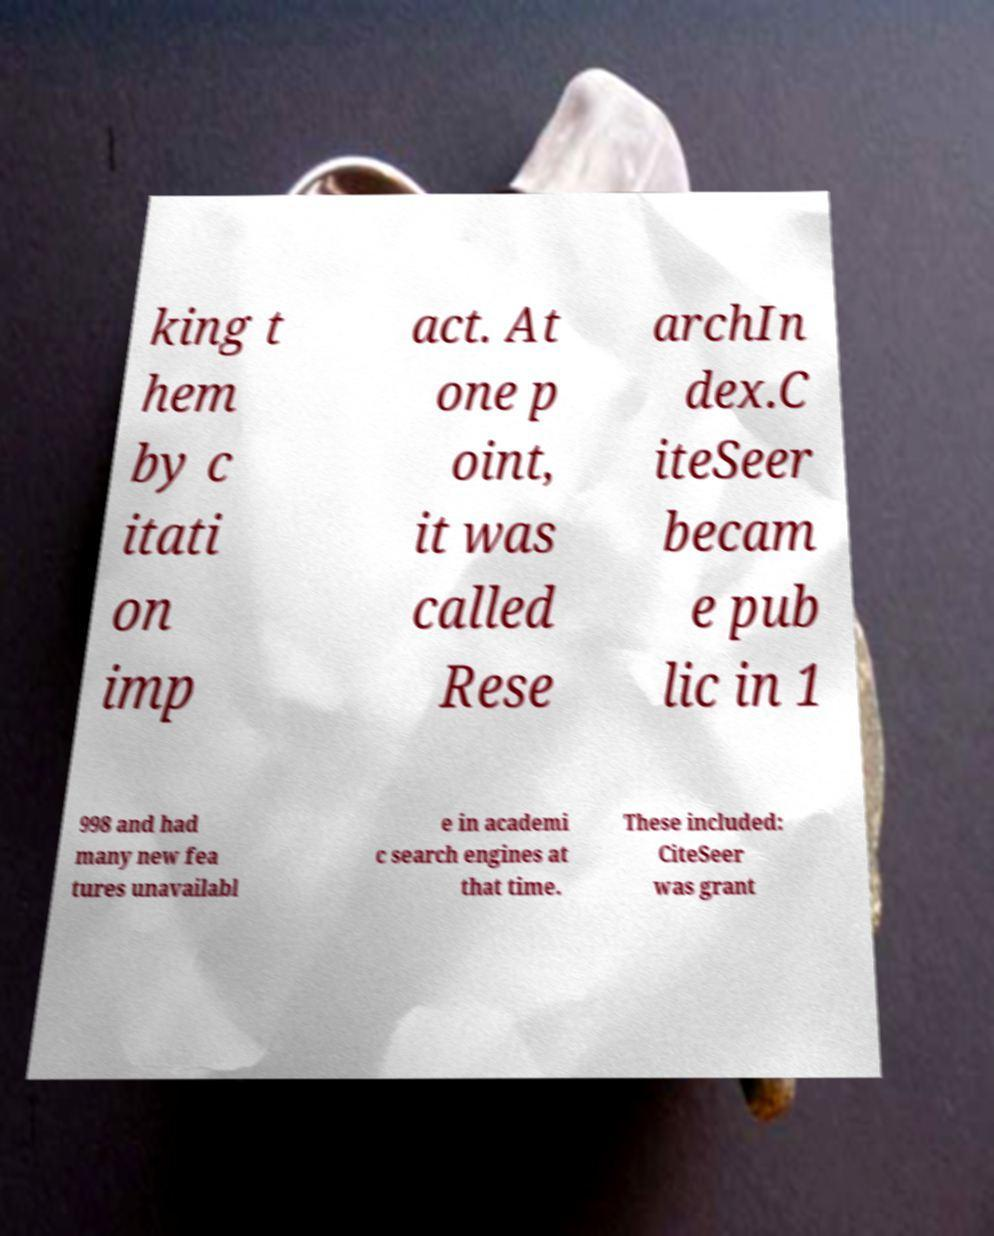Can you accurately transcribe the text from the provided image for me? king t hem by c itati on imp act. At one p oint, it was called Rese archIn dex.C iteSeer becam e pub lic in 1 998 and had many new fea tures unavailabl e in academi c search engines at that time. These included: CiteSeer was grant 